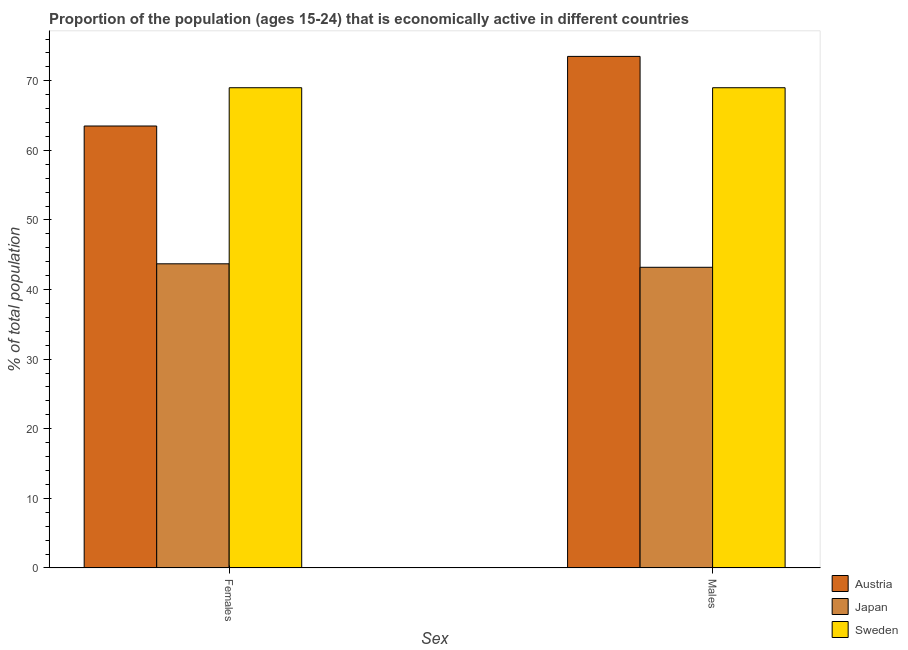How many different coloured bars are there?
Provide a short and direct response. 3. How many groups of bars are there?
Ensure brevity in your answer.  2. Are the number of bars per tick equal to the number of legend labels?
Keep it short and to the point. Yes. Are the number of bars on each tick of the X-axis equal?
Make the answer very short. Yes. How many bars are there on the 1st tick from the left?
Your answer should be very brief. 3. How many bars are there on the 1st tick from the right?
Give a very brief answer. 3. What is the label of the 2nd group of bars from the left?
Offer a very short reply. Males. What is the percentage of economically active female population in Austria?
Provide a succinct answer. 63.5. Across all countries, what is the maximum percentage of economically active male population?
Your answer should be very brief. 73.5. Across all countries, what is the minimum percentage of economically active female population?
Your answer should be compact. 43.7. In which country was the percentage of economically active male population maximum?
Make the answer very short. Austria. In which country was the percentage of economically active male population minimum?
Provide a succinct answer. Japan. What is the total percentage of economically active female population in the graph?
Ensure brevity in your answer.  176.2. What is the average percentage of economically active male population per country?
Make the answer very short. 61.9. What is the ratio of the percentage of economically active female population in Sweden to that in Austria?
Give a very brief answer. 1.09. Is the percentage of economically active female population in Austria less than that in Japan?
Offer a very short reply. No. What does the 3rd bar from the right in Females represents?
Your answer should be very brief. Austria. How many countries are there in the graph?
Your answer should be compact. 3. What is the difference between two consecutive major ticks on the Y-axis?
Your response must be concise. 10. Are the values on the major ticks of Y-axis written in scientific E-notation?
Your response must be concise. No. What is the title of the graph?
Your response must be concise. Proportion of the population (ages 15-24) that is economically active in different countries. What is the label or title of the X-axis?
Offer a very short reply. Sex. What is the label or title of the Y-axis?
Provide a succinct answer. % of total population. What is the % of total population in Austria in Females?
Offer a very short reply. 63.5. What is the % of total population of Japan in Females?
Keep it short and to the point. 43.7. What is the % of total population of Austria in Males?
Ensure brevity in your answer.  73.5. What is the % of total population in Japan in Males?
Your answer should be compact. 43.2. Across all Sex, what is the maximum % of total population in Austria?
Your answer should be compact. 73.5. Across all Sex, what is the maximum % of total population in Japan?
Offer a very short reply. 43.7. Across all Sex, what is the maximum % of total population of Sweden?
Your answer should be very brief. 69. Across all Sex, what is the minimum % of total population of Austria?
Provide a succinct answer. 63.5. Across all Sex, what is the minimum % of total population of Japan?
Offer a very short reply. 43.2. What is the total % of total population of Austria in the graph?
Provide a succinct answer. 137. What is the total % of total population of Japan in the graph?
Make the answer very short. 86.9. What is the total % of total population in Sweden in the graph?
Offer a terse response. 138. What is the difference between the % of total population in Japan in Females and that in Males?
Your response must be concise. 0.5. What is the difference between the % of total population in Sweden in Females and that in Males?
Offer a very short reply. 0. What is the difference between the % of total population of Austria in Females and the % of total population of Japan in Males?
Offer a very short reply. 20.3. What is the difference between the % of total population in Austria in Females and the % of total population in Sweden in Males?
Provide a short and direct response. -5.5. What is the difference between the % of total population in Japan in Females and the % of total population in Sweden in Males?
Keep it short and to the point. -25.3. What is the average % of total population of Austria per Sex?
Provide a succinct answer. 68.5. What is the average % of total population in Japan per Sex?
Your answer should be compact. 43.45. What is the difference between the % of total population in Austria and % of total population in Japan in Females?
Provide a succinct answer. 19.8. What is the difference between the % of total population of Austria and % of total population of Sweden in Females?
Provide a short and direct response. -5.5. What is the difference between the % of total population in Japan and % of total population in Sweden in Females?
Offer a terse response. -25.3. What is the difference between the % of total population in Austria and % of total population in Japan in Males?
Provide a short and direct response. 30.3. What is the difference between the % of total population of Austria and % of total population of Sweden in Males?
Provide a short and direct response. 4.5. What is the difference between the % of total population in Japan and % of total population in Sweden in Males?
Ensure brevity in your answer.  -25.8. What is the ratio of the % of total population in Austria in Females to that in Males?
Make the answer very short. 0.86. What is the ratio of the % of total population of Japan in Females to that in Males?
Provide a short and direct response. 1.01. What is the difference between the highest and the second highest % of total population in Sweden?
Your response must be concise. 0. What is the difference between the highest and the lowest % of total population in Austria?
Provide a short and direct response. 10. What is the difference between the highest and the lowest % of total population in Sweden?
Offer a very short reply. 0. 